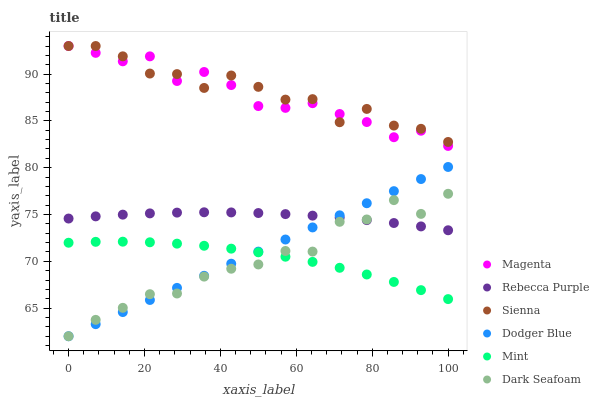Does Dark Seafoam have the minimum area under the curve?
Answer yes or no. Yes. Does Sienna have the maximum area under the curve?
Answer yes or no. Yes. Does Dodger Blue have the minimum area under the curve?
Answer yes or no. No. Does Dodger Blue have the maximum area under the curve?
Answer yes or no. No. Is Dodger Blue the smoothest?
Answer yes or no. Yes. Is Sienna the roughest?
Answer yes or no. Yes. Is Dark Seafoam the smoothest?
Answer yes or no. No. Is Dark Seafoam the roughest?
Answer yes or no. No. Does Dark Seafoam have the lowest value?
Answer yes or no. Yes. Does Rebecca Purple have the lowest value?
Answer yes or no. No. Does Magenta have the highest value?
Answer yes or no. Yes. Does Dark Seafoam have the highest value?
Answer yes or no. No. Is Mint less than Magenta?
Answer yes or no. Yes. Is Sienna greater than Dodger Blue?
Answer yes or no. Yes. Does Mint intersect Dodger Blue?
Answer yes or no. Yes. Is Mint less than Dodger Blue?
Answer yes or no. No. Is Mint greater than Dodger Blue?
Answer yes or no. No. Does Mint intersect Magenta?
Answer yes or no. No. 